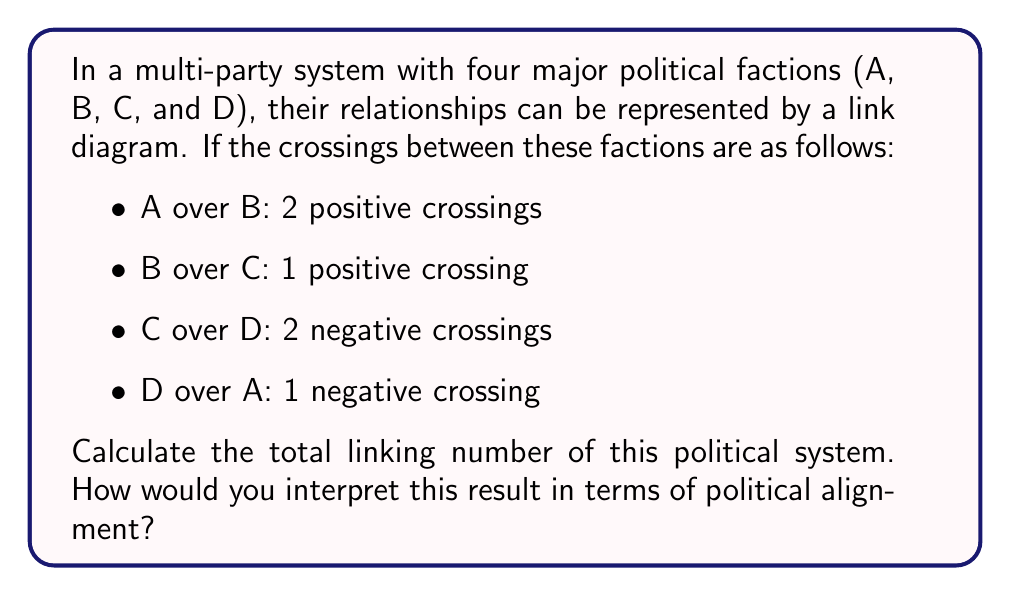Show me your answer to this math problem. To solve this problem, we'll use the concept of linking number from Knot Theory and apply it to our political scenario:

1. Recall the formula for linking number:
   $$Lk = \frac{1}{2}\sum_{i} \epsilon_{i}$$
   where $\epsilon_{i}$ is +1 for positive crossings and -1 for negative crossings.

2. Count the crossings:
   - A over B: 2 positive crossings (+2)
   - B over C: 1 positive crossing (+1)
   - C over D: 2 negative crossings (-2)
   - D over A: 1 negative crossing (-1)

3. Sum up all crossings:
   $$\sum_{i} \epsilon_{i} = 2 + 1 + (-2) + (-1) = 0$$

4. Apply the linking number formula:
   $$Lk = \frac{1}{2} \cdot 0 = 0$$

Interpretation: A linking number of 0 suggests that the political factions are equally balanced in their relationships, with no overall dominant alignment. This could indicate a complex political landscape where alliances and oppositions cancel each other out, potentially leading to a stable but challenging governance situation.
Answer: $Lk = 0$ 